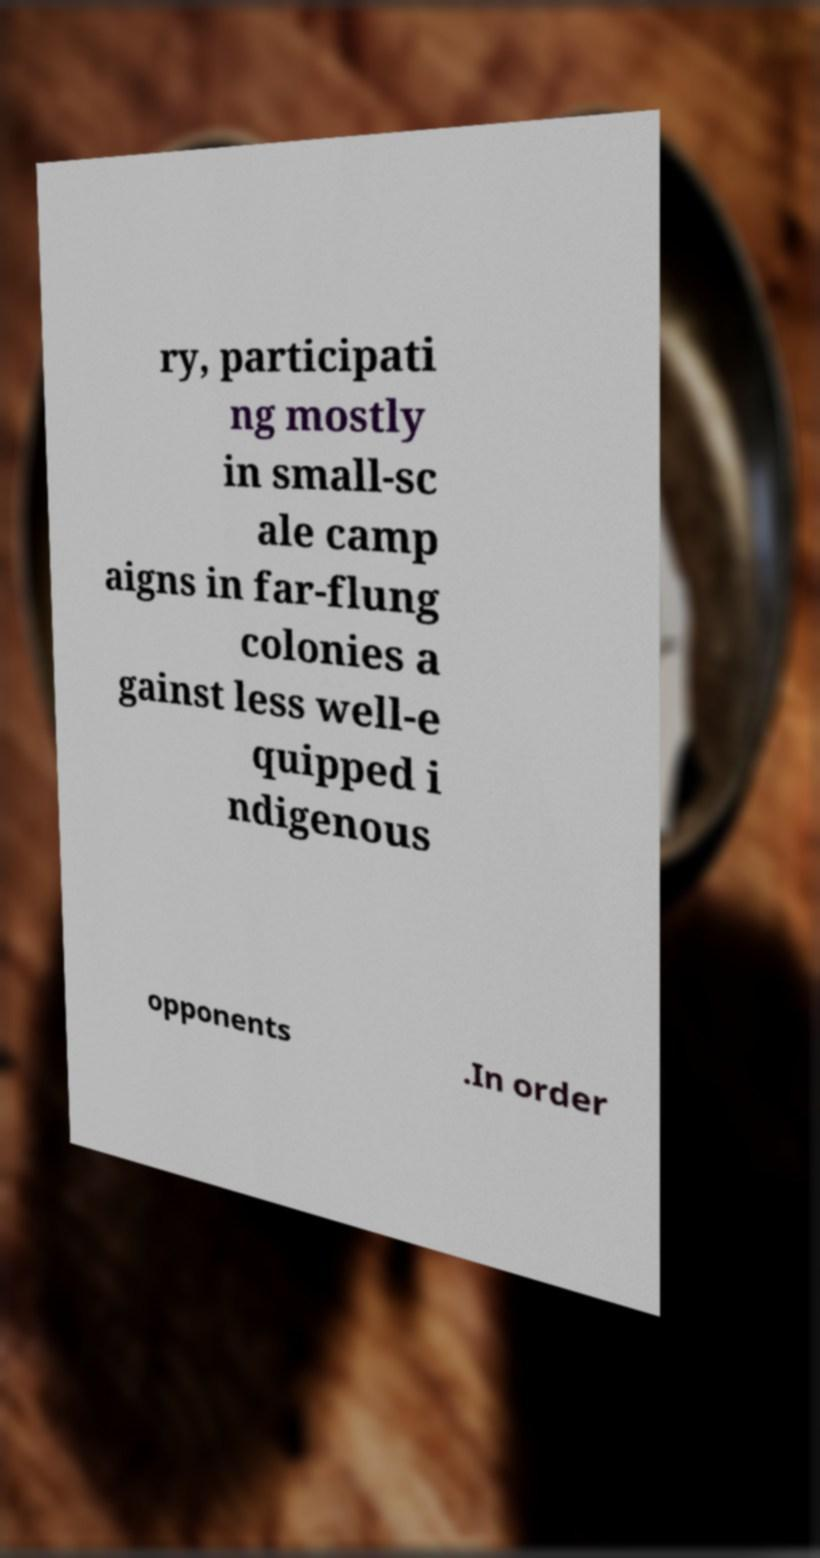Please read and relay the text visible in this image. What does it say? ry, participati ng mostly in small-sc ale camp aigns in far-flung colonies a gainst less well-e quipped i ndigenous opponents .In order 